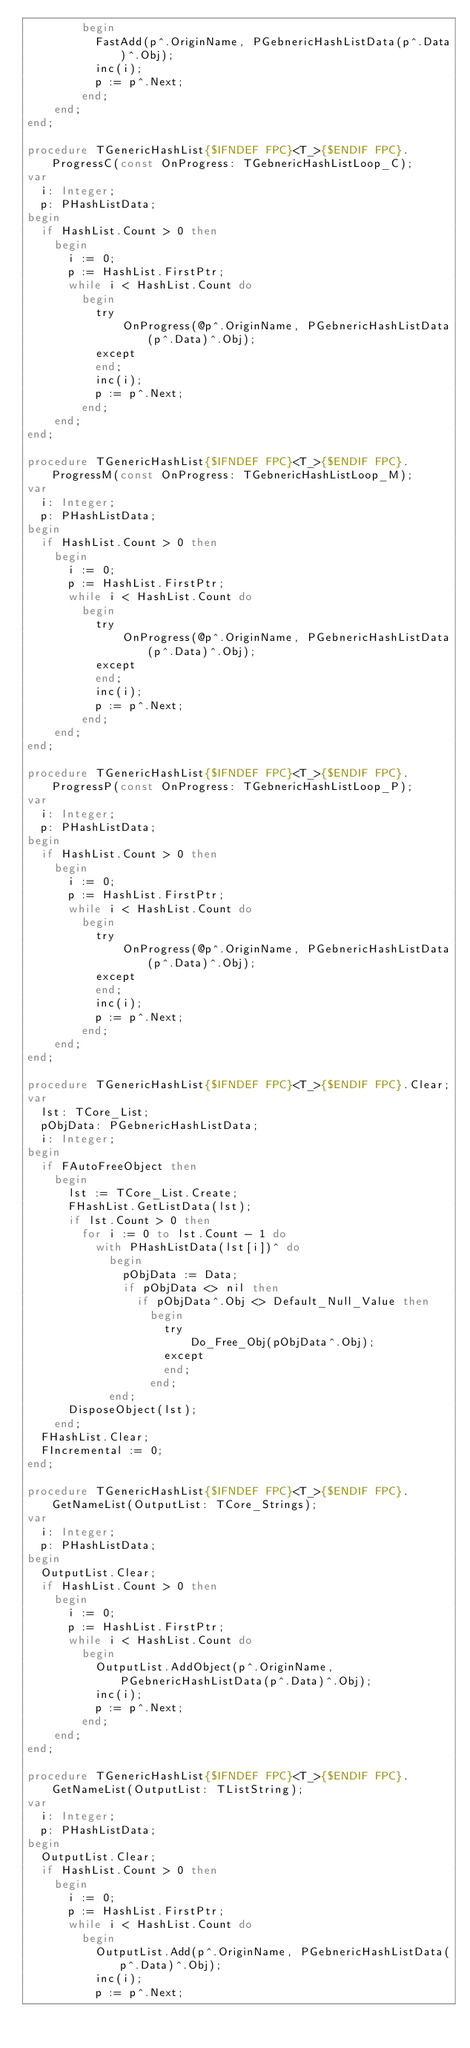Convert code to text. <code><loc_0><loc_0><loc_500><loc_500><_Pascal_>        begin
          FastAdd(p^.OriginName, PGebnericHashListData(p^.Data)^.Obj);
          inc(i);
          p := p^.Next;
        end;
    end;
end;

procedure TGenericHashList{$IFNDEF FPC}<T_>{$ENDIF FPC}.ProgressC(const OnProgress: TGebnericHashListLoop_C);
var
  i: Integer;
  p: PHashListData;
begin
  if HashList.Count > 0 then
    begin
      i := 0;
      p := HashList.FirstPtr;
      while i < HashList.Count do
        begin
          try
              OnProgress(@p^.OriginName, PGebnericHashListData(p^.Data)^.Obj);
          except
          end;
          inc(i);
          p := p^.Next;
        end;
    end;
end;

procedure TGenericHashList{$IFNDEF FPC}<T_>{$ENDIF FPC}.ProgressM(const OnProgress: TGebnericHashListLoop_M);
var
  i: Integer;
  p: PHashListData;
begin
  if HashList.Count > 0 then
    begin
      i := 0;
      p := HashList.FirstPtr;
      while i < HashList.Count do
        begin
          try
              OnProgress(@p^.OriginName, PGebnericHashListData(p^.Data)^.Obj);
          except
          end;
          inc(i);
          p := p^.Next;
        end;
    end;
end;

procedure TGenericHashList{$IFNDEF FPC}<T_>{$ENDIF FPC}.ProgressP(const OnProgress: TGebnericHashListLoop_P);
var
  i: Integer;
  p: PHashListData;
begin
  if HashList.Count > 0 then
    begin
      i := 0;
      p := HashList.FirstPtr;
      while i < HashList.Count do
        begin
          try
              OnProgress(@p^.OriginName, PGebnericHashListData(p^.Data)^.Obj);
          except
          end;
          inc(i);
          p := p^.Next;
        end;
    end;
end;

procedure TGenericHashList{$IFNDEF FPC}<T_>{$ENDIF FPC}.Clear;
var
  lst: TCore_List;
  pObjData: PGebnericHashListData;
  i: Integer;
begin
  if FAutoFreeObject then
    begin
      lst := TCore_List.Create;
      FHashList.GetListData(lst);
      if lst.Count > 0 then
        for i := 0 to lst.Count - 1 do
          with PHashListData(lst[i])^ do
            begin
              pObjData := Data;
              if pObjData <> nil then
                if pObjData^.Obj <> Default_Null_Value then
                  begin
                    try
                        Do_Free_Obj(pObjData^.Obj);
                    except
                    end;
                  end;
            end;
      DisposeObject(lst);
    end;
  FHashList.Clear;
  FIncremental := 0;
end;

procedure TGenericHashList{$IFNDEF FPC}<T_>{$ENDIF FPC}.GetNameList(OutputList: TCore_Strings);
var
  i: Integer;
  p: PHashListData;
begin
  OutputList.Clear;
  if HashList.Count > 0 then
    begin
      i := 0;
      p := HashList.FirstPtr;
      while i < HashList.Count do
        begin
          OutputList.AddObject(p^.OriginName, PGebnericHashListData(p^.Data)^.Obj);
          inc(i);
          p := p^.Next;
        end;
    end;
end;

procedure TGenericHashList{$IFNDEF FPC}<T_>{$ENDIF FPC}.GetNameList(OutputList: TListString);
var
  i: Integer;
  p: PHashListData;
begin
  OutputList.Clear;
  if HashList.Count > 0 then
    begin
      i := 0;
      p := HashList.FirstPtr;
      while i < HashList.Count do
        begin
          OutputList.Add(p^.OriginName, PGebnericHashListData(p^.Data)^.Obj);
          inc(i);
          p := p^.Next;</code> 